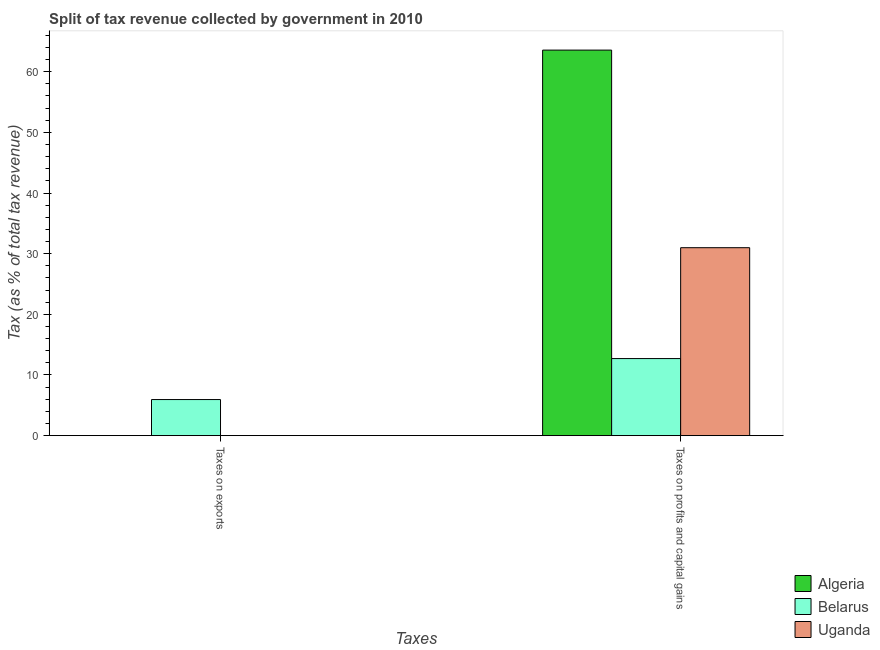How many groups of bars are there?
Make the answer very short. 2. Are the number of bars per tick equal to the number of legend labels?
Make the answer very short. Yes. What is the label of the 1st group of bars from the left?
Offer a terse response. Taxes on exports. What is the percentage of revenue obtained from taxes on exports in Uganda?
Your response must be concise. 0. Across all countries, what is the maximum percentage of revenue obtained from taxes on exports?
Keep it short and to the point. 5.95. Across all countries, what is the minimum percentage of revenue obtained from taxes on exports?
Ensure brevity in your answer.  0. In which country was the percentage of revenue obtained from taxes on profits and capital gains maximum?
Keep it short and to the point. Algeria. In which country was the percentage of revenue obtained from taxes on profits and capital gains minimum?
Give a very brief answer. Belarus. What is the total percentage of revenue obtained from taxes on profits and capital gains in the graph?
Offer a terse response. 107.25. What is the difference between the percentage of revenue obtained from taxes on exports in Algeria and that in Belarus?
Keep it short and to the point. -5.95. What is the difference between the percentage of revenue obtained from taxes on exports in Belarus and the percentage of revenue obtained from taxes on profits and capital gains in Uganda?
Make the answer very short. -25.03. What is the average percentage of revenue obtained from taxes on profits and capital gains per country?
Provide a short and direct response. 35.75. What is the difference between the percentage of revenue obtained from taxes on profits and capital gains and percentage of revenue obtained from taxes on exports in Algeria?
Ensure brevity in your answer.  63.56. What is the ratio of the percentage of revenue obtained from taxes on exports in Uganda to that in Belarus?
Make the answer very short. 0. Is the percentage of revenue obtained from taxes on profits and capital gains in Algeria less than that in Belarus?
Your answer should be compact. No. In how many countries, is the percentage of revenue obtained from taxes on exports greater than the average percentage of revenue obtained from taxes on exports taken over all countries?
Keep it short and to the point. 1. What does the 3rd bar from the left in Taxes on exports represents?
Ensure brevity in your answer.  Uganda. What does the 3rd bar from the right in Taxes on exports represents?
Provide a short and direct response. Algeria. Are all the bars in the graph horizontal?
Make the answer very short. No. How many countries are there in the graph?
Provide a succinct answer. 3. What is the difference between two consecutive major ticks on the Y-axis?
Give a very brief answer. 10. Does the graph contain any zero values?
Make the answer very short. No. Where does the legend appear in the graph?
Give a very brief answer. Bottom right. How are the legend labels stacked?
Offer a very short reply. Vertical. What is the title of the graph?
Your answer should be compact. Split of tax revenue collected by government in 2010. What is the label or title of the X-axis?
Keep it short and to the point. Taxes. What is the label or title of the Y-axis?
Offer a terse response. Tax (as % of total tax revenue). What is the Tax (as % of total tax revenue) in Algeria in Taxes on exports?
Your response must be concise. 0. What is the Tax (as % of total tax revenue) of Belarus in Taxes on exports?
Make the answer very short. 5.95. What is the Tax (as % of total tax revenue) of Uganda in Taxes on exports?
Give a very brief answer. 0. What is the Tax (as % of total tax revenue) of Algeria in Taxes on profits and capital gains?
Ensure brevity in your answer.  63.56. What is the Tax (as % of total tax revenue) of Belarus in Taxes on profits and capital gains?
Offer a terse response. 12.71. What is the Tax (as % of total tax revenue) of Uganda in Taxes on profits and capital gains?
Make the answer very short. 30.98. Across all Taxes, what is the maximum Tax (as % of total tax revenue) in Algeria?
Ensure brevity in your answer.  63.56. Across all Taxes, what is the maximum Tax (as % of total tax revenue) in Belarus?
Provide a succinct answer. 12.71. Across all Taxes, what is the maximum Tax (as % of total tax revenue) in Uganda?
Keep it short and to the point. 30.98. Across all Taxes, what is the minimum Tax (as % of total tax revenue) in Algeria?
Give a very brief answer. 0. Across all Taxes, what is the minimum Tax (as % of total tax revenue) in Belarus?
Offer a very short reply. 5.95. Across all Taxes, what is the minimum Tax (as % of total tax revenue) in Uganda?
Offer a very short reply. 0. What is the total Tax (as % of total tax revenue) of Algeria in the graph?
Ensure brevity in your answer.  63.56. What is the total Tax (as % of total tax revenue) of Belarus in the graph?
Offer a very short reply. 18.66. What is the total Tax (as % of total tax revenue) in Uganda in the graph?
Offer a terse response. 30.99. What is the difference between the Tax (as % of total tax revenue) in Algeria in Taxes on exports and that in Taxes on profits and capital gains?
Offer a very short reply. -63.56. What is the difference between the Tax (as % of total tax revenue) in Belarus in Taxes on exports and that in Taxes on profits and capital gains?
Offer a terse response. -6.76. What is the difference between the Tax (as % of total tax revenue) of Uganda in Taxes on exports and that in Taxes on profits and capital gains?
Give a very brief answer. -30.98. What is the difference between the Tax (as % of total tax revenue) in Algeria in Taxes on exports and the Tax (as % of total tax revenue) in Belarus in Taxes on profits and capital gains?
Your answer should be very brief. -12.71. What is the difference between the Tax (as % of total tax revenue) in Algeria in Taxes on exports and the Tax (as % of total tax revenue) in Uganda in Taxes on profits and capital gains?
Your answer should be very brief. -30.98. What is the difference between the Tax (as % of total tax revenue) in Belarus in Taxes on exports and the Tax (as % of total tax revenue) in Uganda in Taxes on profits and capital gains?
Keep it short and to the point. -25.03. What is the average Tax (as % of total tax revenue) in Algeria per Taxes?
Provide a short and direct response. 31.78. What is the average Tax (as % of total tax revenue) of Belarus per Taxes?
Keep it short and to the point. 9.33. What is the average Tax (as % of total tax revenue) of Uganda per Taxes?
Your answer should be very brief. 15.49. What is the difference between the Tax (as % of total tax revenue) of Algeria and Tax (as % of total tax revenue) of Belarus in Taxes on exports?
Ensure brevity in your answer.  -5.95. What is the difference between the Tax (as % of total tax revenue) of Algeria and Tax (as % of total tax revenue) of Uganda in Taxes on exports?
Ensure brevity in your answer.  -0. What is the difference between the Tax (as % of total tax revenue) in Belarus and Tax (as % of total tax revenue) in Uganda in Taxes on exports?
Your answer should be very brief. 5.95. What is the difference between the Tax (as % of total tax revenue) of Algeria and Tax (as % of total tax revenue) of Belarus in Taxes on profits and capital gains?
Provide a short and direct response. 50.85. What is the difference between the Tax (as % of total tax revenue) of Algeria and Tax (as % of total tax revenue) of Uganda in Taxes on profits and capital gains?
Keep it short and to the point. 32.58. What is the difference between the Tax (as % of total tax revenue) in Belarus and Tax (as % of total tax revenue) in Uganda in Taxes on profits and capital gains?
Offer a very short reply. -18.28. What is the ratio of the Tax (as % of total tax revenue) of Belarus in Taxes on exports to that in Taxes on profits and capital gains?
Offer a terse response. 0.47. What is the ratio of the Tax (as % of total tax revenue) of Uganda in Taxes on exports to that in Taxes on profits and capital gains?
Offer a terse response. 0. What is the difference between the highest and the second highest Tax (as % of total tax revenue) in Algeria?
Make the answer very short. 63.56. What is the difference between the highest and the second highest Tax (as % of total tax revenue) of Belarus?
Offer a terse response. 6.76. What is the difference between the highest and the second highest Tax (as % of total tax revenue) in Uganda?
Keep it short and to the point. 30.98. What is the difference between the highest and the lowest Tax (as % of total tax revenue) of Algeria?
Your response must be concise. 63.56. What is the difference between the highest and the lowest Tax (as % of total tax revenue) of Belarus?
Offer a terse response. 6.76. What is the difference between the highest and the lowest Tax (as % of total tax revenue) in Uganda?
Keep it short and to the point. 30.98. 